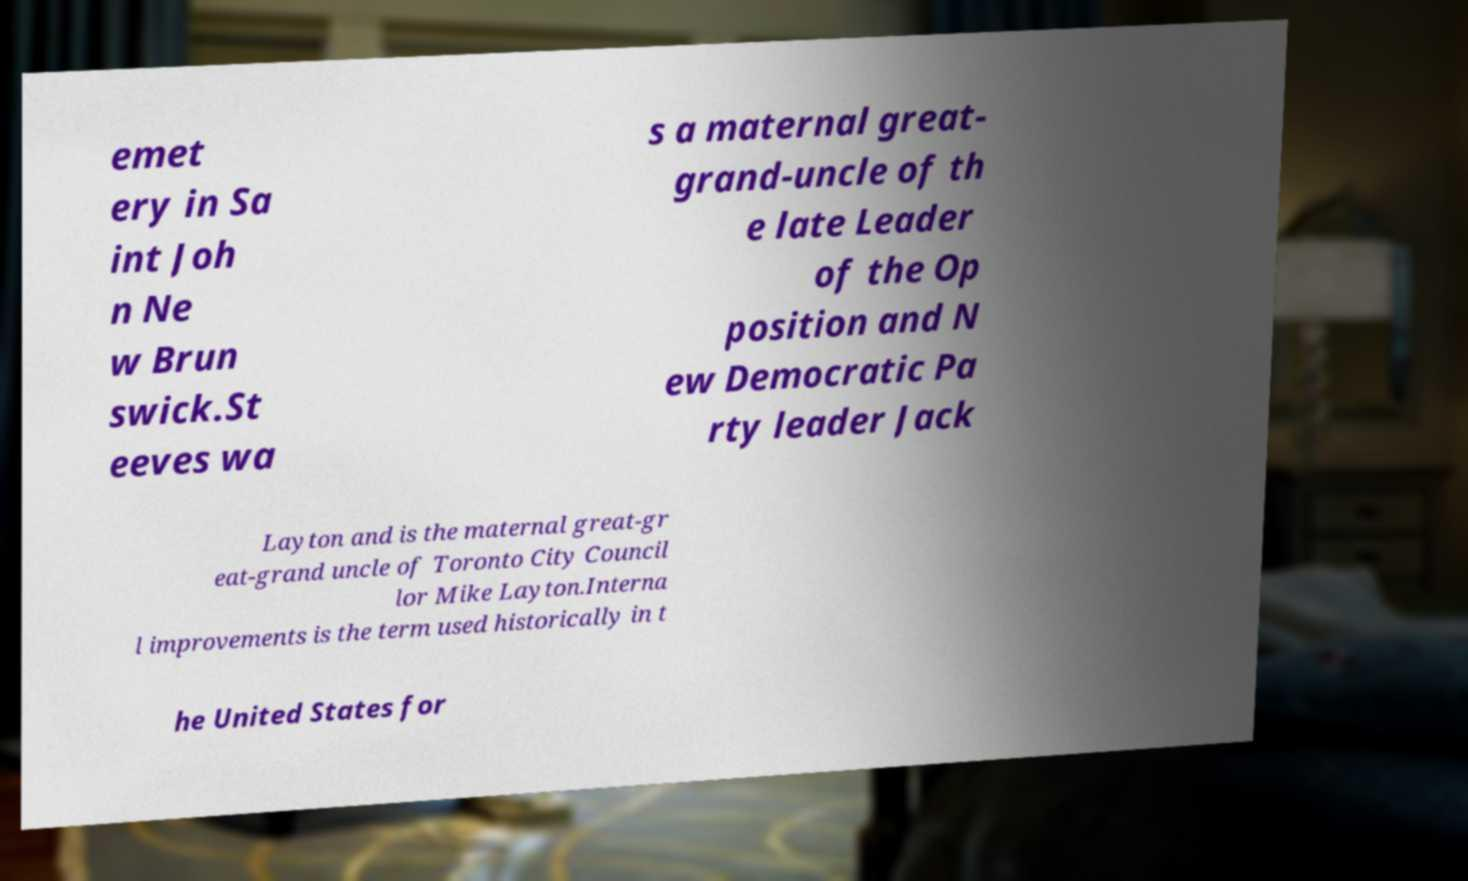What messages or text are displayed in this image? I need them in a readable, typed format. emet ery in Sa int Joh n Ne w Brun swick.St eeves wa s a maternal great- grand-uncle of th e late Leader of the Op position and N ew Democratic Pa rty leader Jack Layton and is the maternal great-gr eat-grand uncle of Toronto City Council lor Mike Layton.Interna l improvements is the term used historically in t he United States for 